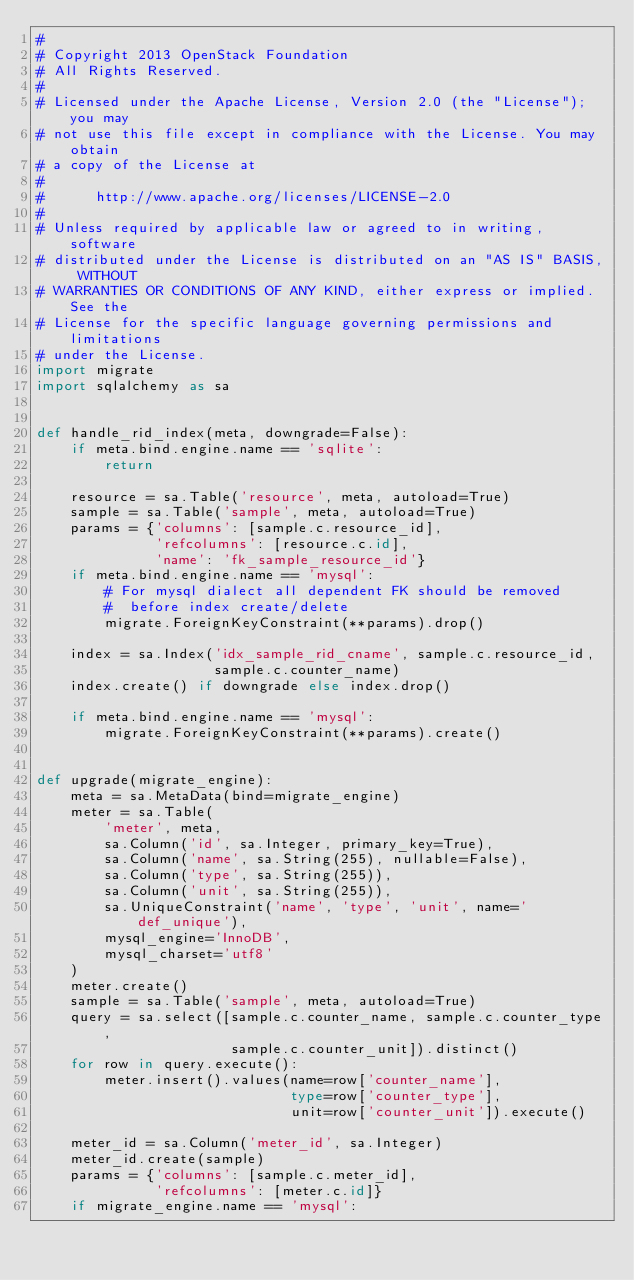Convert code to text. <code><loc_0><loc_0><loc_500><loc_500><_Python_>#
# Copyright 2013 OpenStack Foundation
# All Rights Reserved.
#
# Licensed under the Apache License, Version 2.0 (the "License"); you may
# not use this file except in compliance with the License. You may obtain
# a copy of the License at
#
#      http://www.apache.org/licenses/LICENSE-2.0
#
# Unless required by applicable law or agreed to in writing, software
# distributed under the License is distributed on an "AS IS" BASIS, WITHOUT
# WARRANTIES OR CONDITIONS OF ANY KIND, either express or implied. See the
# License for the specific language governing permissions and limitations
# under the License.
import migrate
import sqlalchemy as sa


def handle_rid_index(meta, downgrade=False):
    if meta.bind.engine.name == 'sqlite':
        return

    resource = sa.Table('resource', meta, autoload=True)
    sample = sa.Table('sample', meta, autoload=True)
    params = {'columns': [sample.c.resource_id],
              'refcolumns': [resource.c.id],
              'name': 'fk_sample_resource_id'}
    if meta.bind.engine.name == 'mysql':
        # For mysql dialect all dependent FK should be removed
        #  before index create/delete
        migrate.ForeignKeyConstraint(**params).drop()

    index = sa.Index('idx_sample_rid_cname', sample.c.resource_id,
                     sample.c.counter_name)
    index.create() if downgrade else index.drop()

    if meta.bind.engine.name == 'mysql':
        migrate.ForeignKeyConstraint(**params).create()


def upgrade(migrate_engine):
    meta = sa.MetaData(bind=migrate_engine)
    meter = sa.Table(
        'meter', meta,
        sa.Column('id', sa.Integer, primary_key=True),
        sa.Column('name', sa.String(255), nullable=False),
        sa.Column('type', sa.String(255)),
        sa.Column('unit', sa.String(255)),
        sa.UniqueConstraint('name', 'type', 'unit', name='def_unique'),
        mysql_engine='InnoDB',
        mysql_charset='utf8'
    )
    meter.create()
    sample = sa.Table('sample', meta, autoload=True)
    query = sa.select([sample.c.counter_name, sample.c.counter_type,
                       sample.c.counter_unit]).distinct()
    for row in query.execute():
        meter.insert().values(name=row['counter_name'],
                              type=row['counter_type'],
                              unit=row['counter_unit']).execute()

    meter_id = sa.Column('meter_id', sa.Integer)
    meter_id.create(sample)
    params = {'columns': [sample.c.meter_id],
              'refcolumns': [meter.c.id]}
    if migrate_engine.name == 'mysql':</code> 